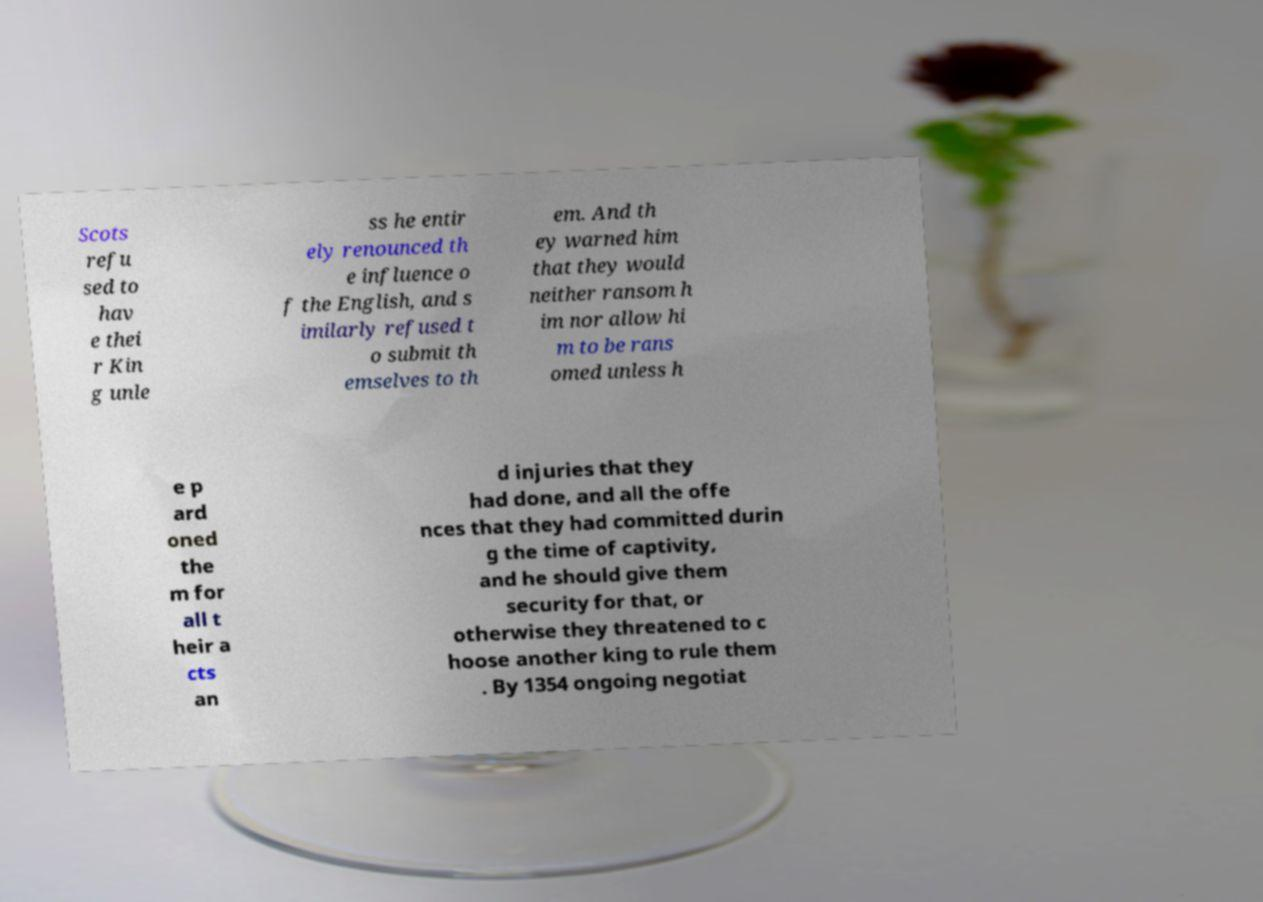What messages or text are displayed in this image? I need them in a readable, typed format. Scots refu sed to hav e thei r Kin g unle ss he entir ely renounced th e influence o f the English, and s imilarly refused t o submit th emselves to th em. And th ey warned him that they would neither ransom h im nor allow hi m to be rans omed unless h e p ard oned the m for all t heir a cts an d injuries that they had done, and all the offe nces that they had committed durin g the time of captivity, and he should give them security for that, or otherwise they threatened to c hoose another king to rule them . By 1354 ongoing negotiat 